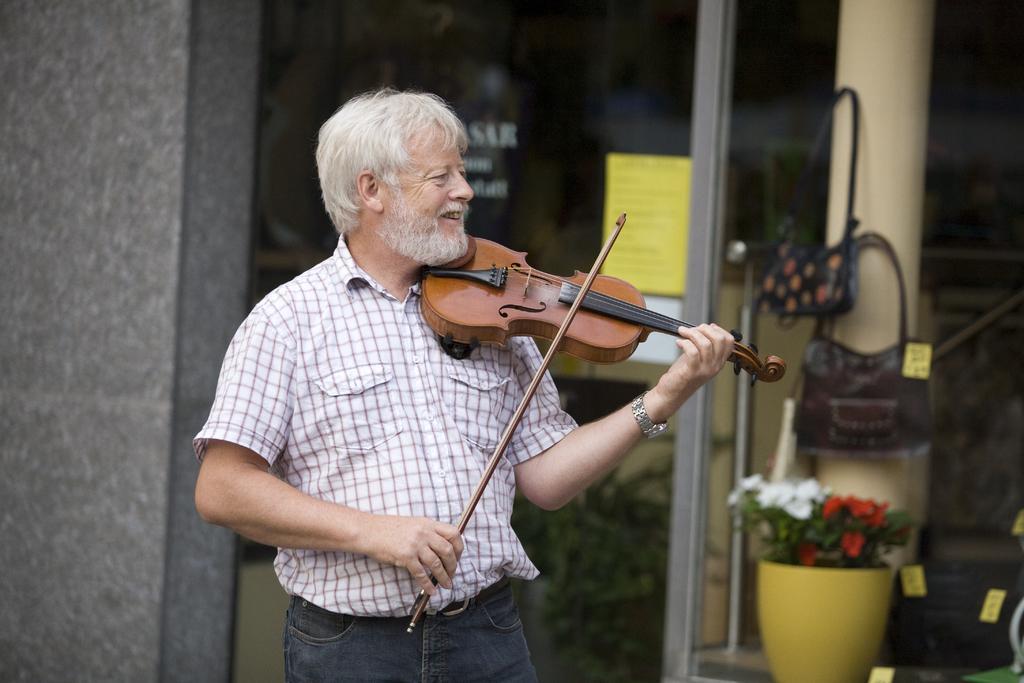In one or two sentences, can you explain what this image depicts? In this image there is a person wearing white color shirt playing violin. At the background of the image there is a house. 